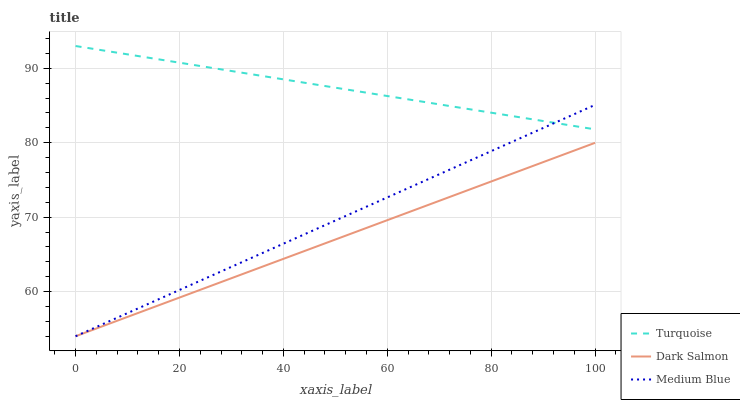Does Dark Salmon have the minimum area under the curve?
Answer yes or no. Yes. Does Turquoise have the maximum area under the curve?
Answer yes or no. Yes. Does Medium Blue have the minimum area under the curve?
Answer yes or no. No. Does Medium Blue have the maximum area under the curve?
Answer yes or no. No. Is Medium Blue the smoothest?
Answer yes or no. Yes. Is Turquoise the roughest?
Answer yes or no. Yes. Is Dark Salmon the smoothest?
Answer yes or no. No. Is Dark Salmon the roughest?
Answer yes or no. No. Does Medium Blue have the lowest value?
Answer yes or no. Yes. Does Turquoise have the highest value?
Answer yes or no. Yes. Does Medium Blue have the highest value?
Answer yes or no. No. Is Dark Salmon less than Turquoise?
Answer yes or no. Yes. Is Turquoise greater than Dark Salmon?
Answer yes or no. Yes. Does Dark Salmon intersect Medium Blue?
Answer yes or no. Yes. Is Dark Salmon less than Medium Blue?
Answer yes or no. No. Is Dark Salmon greater than Medium Blue?
Answer yes or no. No. Does Dark Salmon intersect Turquoise?
Answer yes or no. No. 